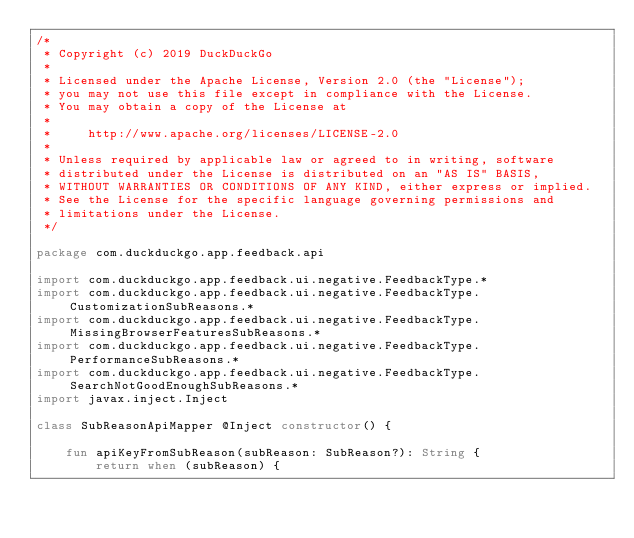Convert code to text. <code><loc_0><loc_0><loc_500><loc_500><_Kotlin_>/*
 * Copyright (c) 2019 DuckDuckGo
 *
 * Licensed under the Apache License, Version 2.0 (the "License");
 * you may not use this file except in compliance with the License.
 * You may obtain a copy of the License at
 *
 *     http://www.apache.org/licenses/LICENSE-2.0
 *
 * Unless required by applicable law or agreed to in writing, software
 * distributed under the License is distributed on an "AS IS" BASIS,
 * WITHOUT WARRANTIES OR CONDITIONS OF ANY KIND, either express or implied.
 * See the License for the specific language governing permissions and
 * limitations under the License.
 */

package com.duckduckgo.app.feedback.api

import com.duckduckgo.app.feedback.ui.negative.FeedbackType.*
import com.duckduckgo.app.feedback.ui.negative.FeedbackType.CustomizationSubReasons.*
import com.duckduckgo.app.feedback.ui.negative.FeedbackType.MissingBrowserFeaturesSubReasons.*
import com.duckduckgo.app.feedback.ui.negative.FeedbackType.PerformanceSubReasons.*
import com.duckduckgo.app.feedback.ui.negative.FeedbackType.SearchNotGoodEnoughSubReasons.*
import javax.inject.Inject

class SubReasonApiMapper @Inject constructor() {

    fun apiKeyFromSubReason(subReason: SubReason?): String {
        return when (subReason) {</code> 